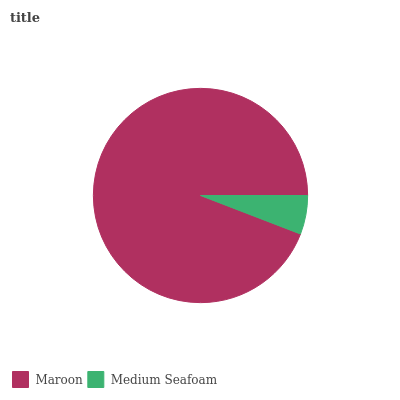Is Medium Seafoam the minimum?
Answer yes or no. Yes. Is Maroon the maximum?
Answer yes or no. Yes. Is Medium Seafoam the maximum?
Answer yes or no. No. Is Maroon greater than Medium Seafoam?
Answer yes or no. Yes. Is Medium Seafoam less than Maroon?
Answer yes or no. Yes. Is Medium Seafoam greater than Maroon?
Answer yes or no. No. Is Maroon less than Medium Seafoam?
Answer yes or no. No. Is Maroon the high median?
Answer yes or no. Yes. Is Medium Seafoam the low median?
Answer yes or no. Yes. Is Medium Seafoam the high median?
Answer yes or no. No. Is Maroon the low median?
Answer yes or no. No. 